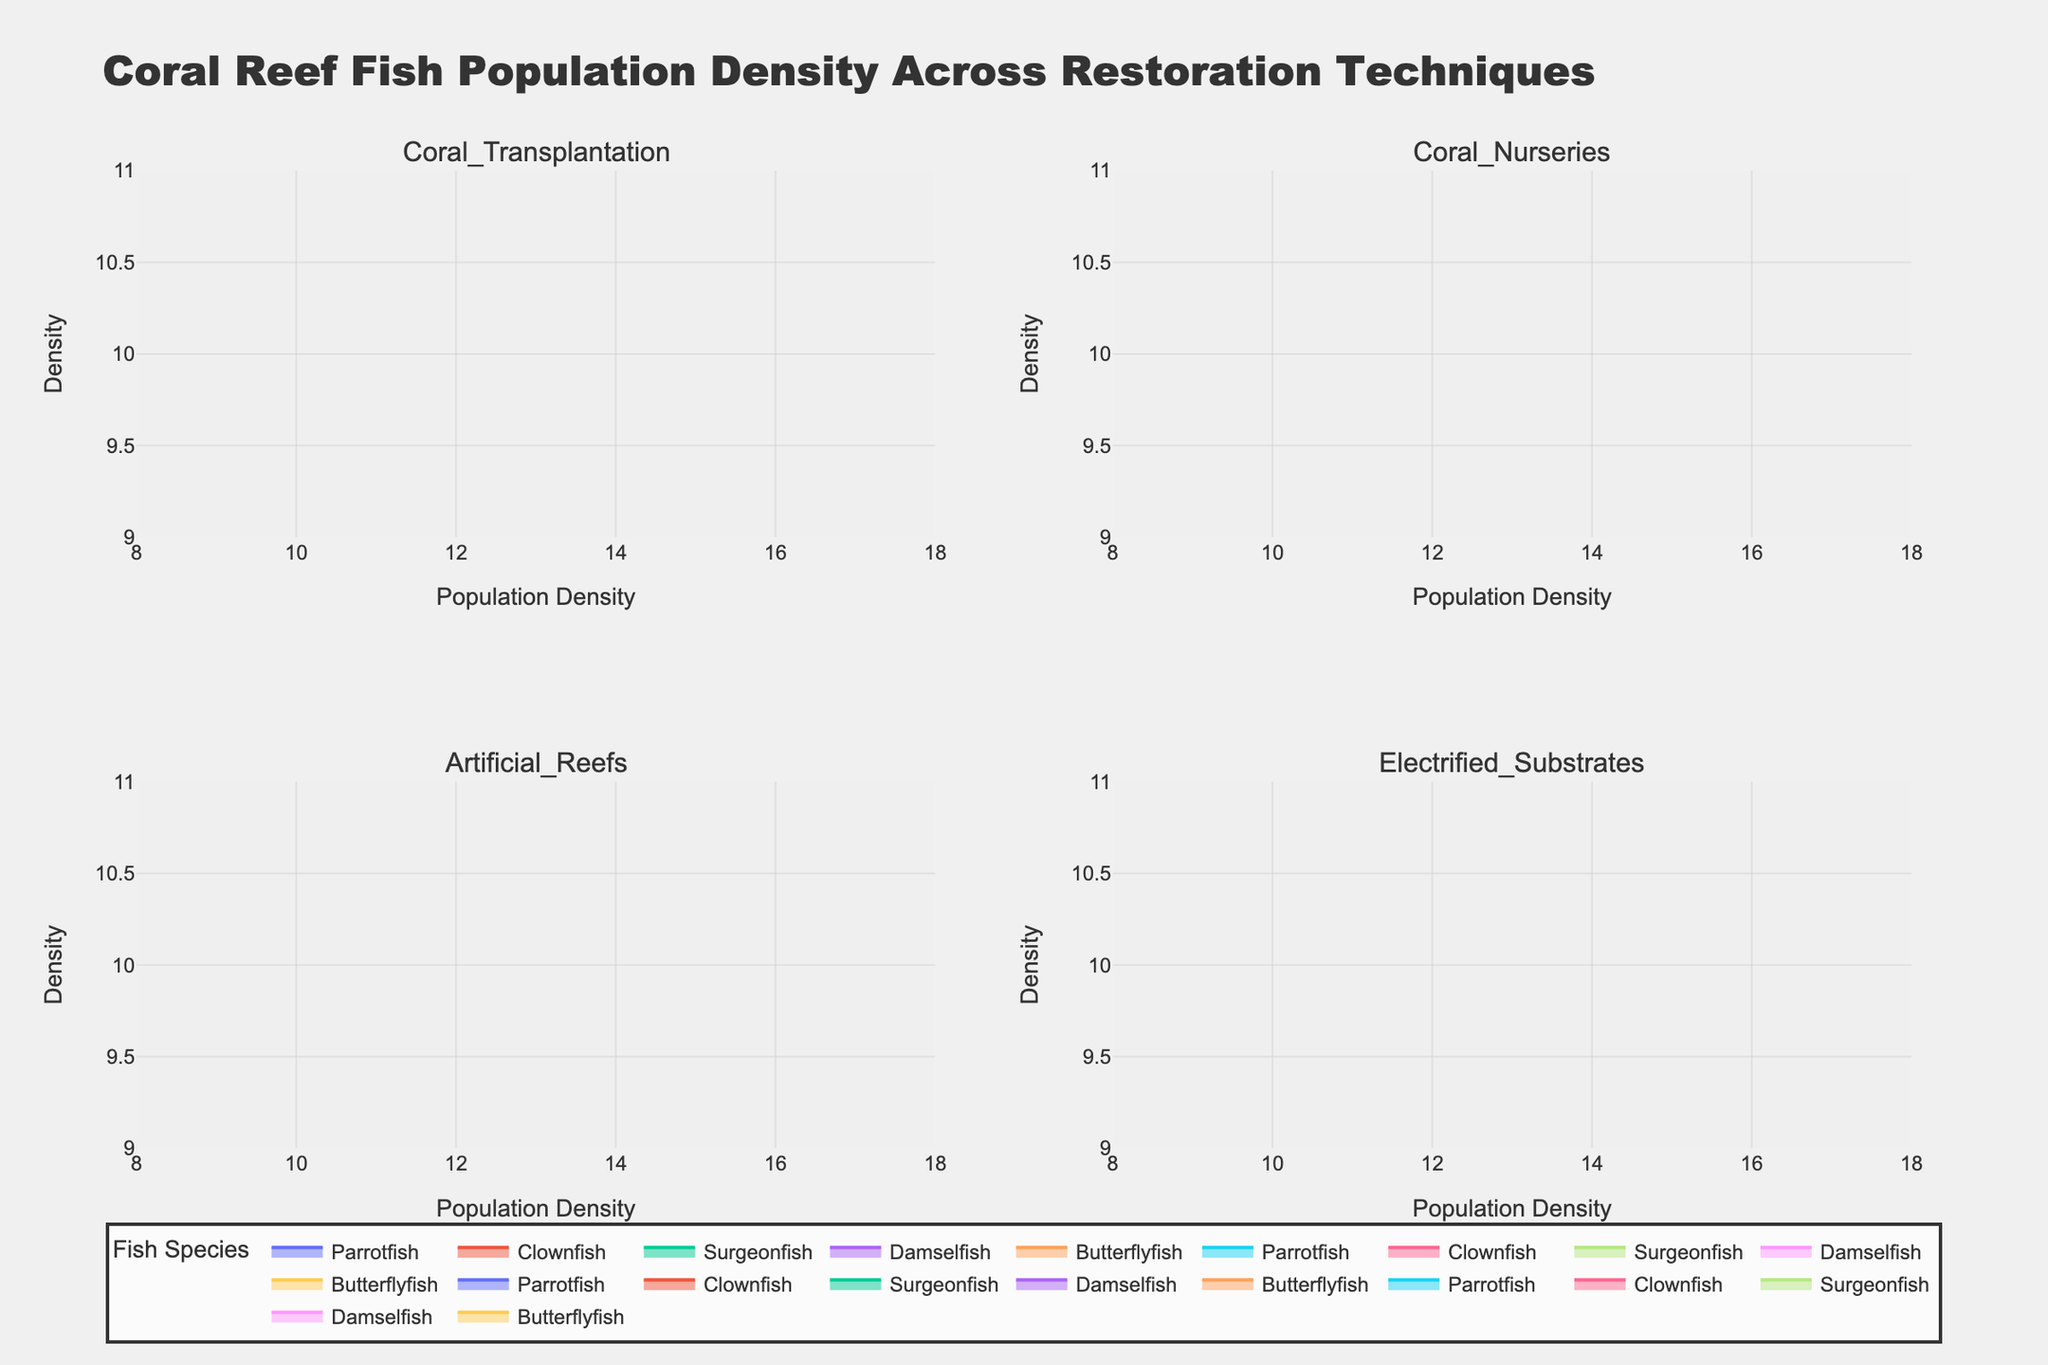What is the title of the figure? The title is usually mentioned at the top of the figure. In this case, it says "Coral Reef Fish Population Density Across Restoration Techniques".
Answer: Coral Reef Fish Population Density Across Restoration Techniques What axes are labeled in this figure, and what are their titles? The x-axis is labeled as "Population Density", and the y-axis is labeled as "Density". You can find these titles along the respective axes in the figure.
Answer: Population Density, Density How many restoration techniques are compared in this figure? The figure has subplots for each restoration technique. By looking at the subplot titles, we can count four techniques being compared.
Answer: Four Which restoration technique shows the highest population density for Clownfish? By checking the Clownfish density curves across all subplots, Electrified Substrates has the highest peak for Clownfish density.
Answer: Electrified Substrates What is the approximate population density range for Parrotfish across all restoration techniques? Look at the x-axis ranges in each subplot for Parrotfish’s density curves. They mainly fall between 10 and 15.
Answer: 10 to 15 Which fish species has the lowest population density in the Electrified Substrates technique? By inspecting the density curves in the Electrified Substrates subplot, Surgeonfish has the lowest population density as indicated by the lowest peak.
Answer: Surgeonfish How does the population density of Butterflyfish in Artificial Reefs compare to that in Coral Nurseries? Comparing the density curves of Butterflyfish in both subplots, the population density is slightly higher in Coral Nurseries than in Artificial Reefs.
Answer: Higher in Coral Nurseries Which restoration technique appears to support the highest overall density for Damselfish? By comparing the density peaks of Damselfish across all subplots, Coral Transplantation shows the highest overall density for this species.
Answer: Coral Transplantation Between Coral Transplantation and Artificial Reefs, which technique shows a higher population density for Surgeonfish? By comparing the density curves for Surgeonfish in both subplots, Artificial Reefs show a higher population density.
Answer: Artificial Reefs 